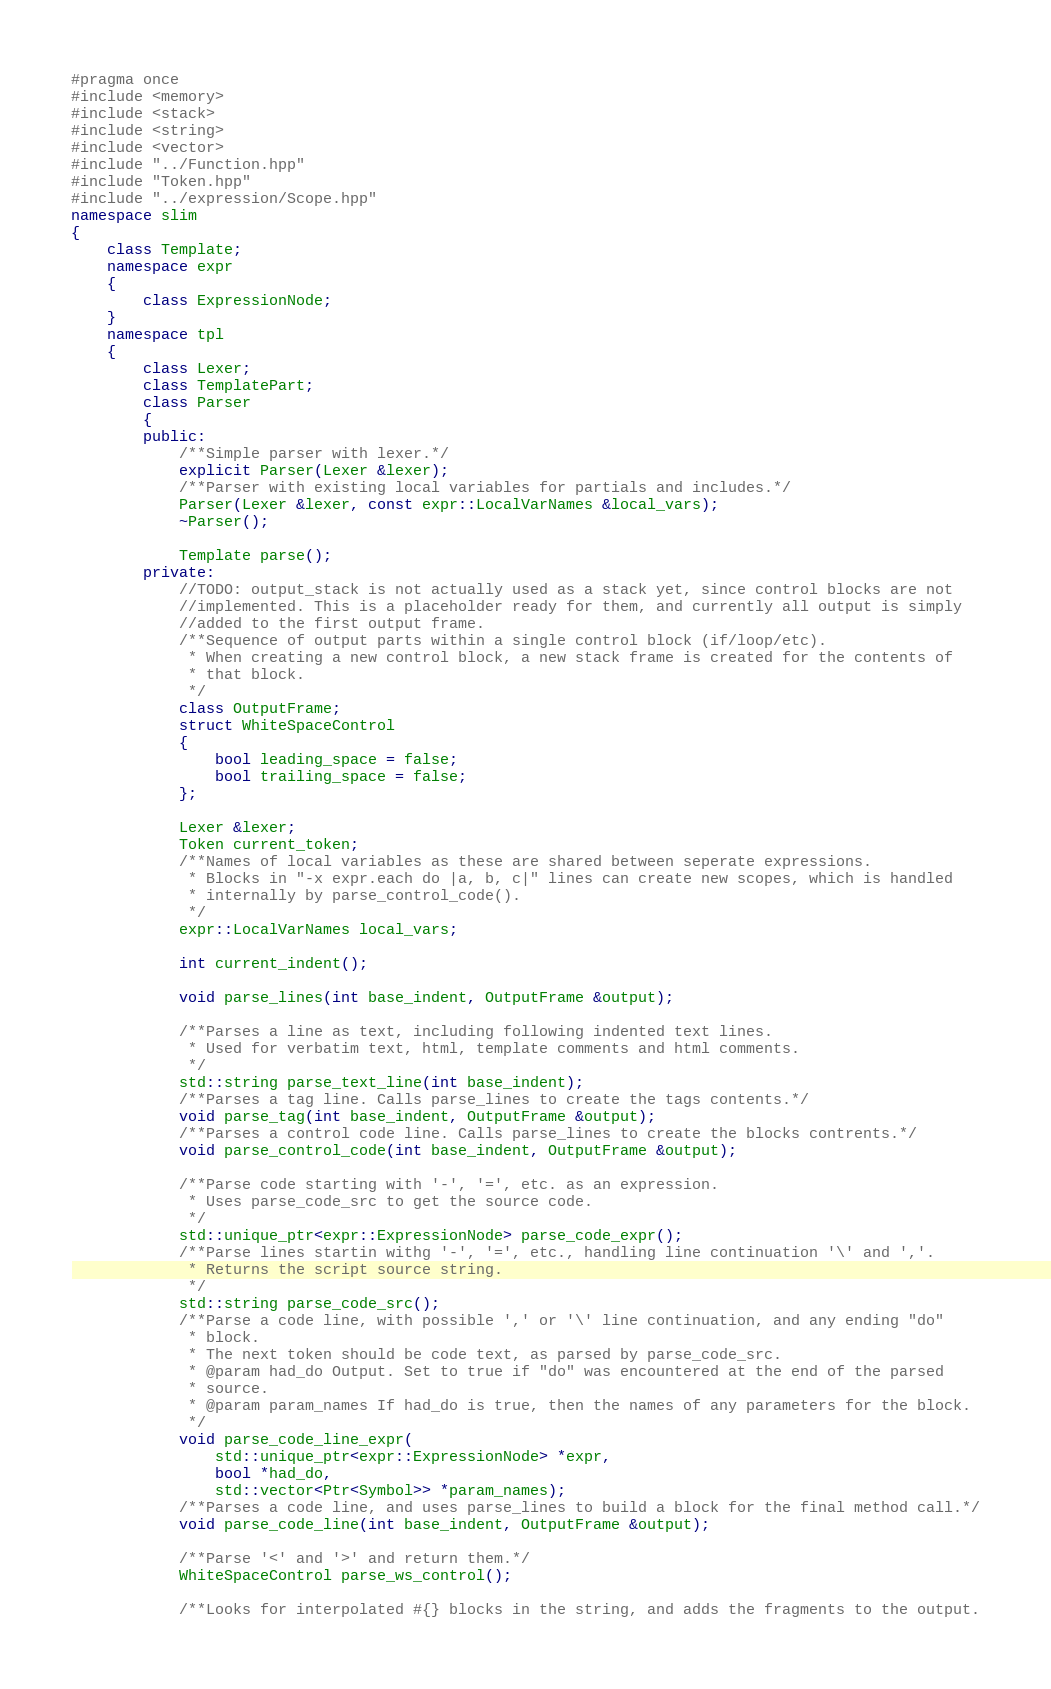Convert code to text. <code><loc_0><loc_0><loc_500><loc_500><_C++_>#pragma once
#include <memory>
#include <stack>
#include <string>
#include <vector>
#include "../Function.hpp"
#include "Token.hpp"
#include "../expression/Scope.hpp"
namespace slim
{
    class Template;
    namespace expr
    {
        class ExpressionNode;
    }
    namespace tpl
    {
        class Lexer;
        class TemplatePart;
        class Parser
        {
        public:
            /**Simple parser with lexer.*/
            explicit Parser(Lexer &lexer);
            /**Parser with existing local variables for partials and includes.*/
            Parser(Lexer &lexer, const expr::LocalVarNames &local_vars);
            ~Parser();

            Template parse();
        private:
            //TODO: output_stack is not actually used as a stack yet, since control blocks are not
            //implemented. This is a placeholder ready for them, and currently all output is simply
            //added to the first output frame.
            /**Sequence of output parts within a single control block (if/loop/etc).
             * When creating a new control block, a new stack frame is created for the contents of
             * that block.
             */
            class OutputFrame;
            struct WhiteSpaceControl
            {
                bool leading_space = false;
                bool trailing_space = false;
            };

            Lexer &lexer;
            Token current_token;
            /**Names of local variables as these are shared between seperate expressions.
             * Blocks in "-x expr.each do |a, b, c|" lines can create new scopes, which is handled
             * internally by parse_control_code().
             */
            expr::LocalVarNames local_vars;

            int current_indent();

            void parse_lines(int base_indent, OutputFrame &output);

            /**Parses a line as text, including following indented text lines.
             * Used for verbatim text, html, template comments and html comments.
             */
            std::string parse_text_line(int base_indent);
            /**Parses a tag line. Calls parse_lines to create the tags contents.*/
            void parse_tag(int base_indent, OutputFrame &output);
            /**Parses a control code line. Calls parse_lines to create the blocks contrents.*/
            void parse_control_code(int base_indent, OutputFrame &output);

            /**Parse code starting with '-', '=', etc. as an expression.
             * Uses parse_code_src to get the source code.
             */
            std::unique_ptr<expr::ExpressionNode> parse_code_expr();
            /**Parse lines startin withg '-', '=', etc., handling line continuation '\' and ','.
             * Returns the script source string.
             */
            std::string parse_code_src();
            /**Parse a code line, with possible ',' or '\' line continuation, and any ending "do"
             * block.
             * The next token should be code text, as parsed by parse_code_src.
             * @param had_do Output. Set to true if "do" was encountered at the end of the parsed
             * source.
             * @param param_names If had_do is true, then the names of any parameters for the block.
             */
            void parse_code_line_expr(
                std::unique_ptr<expr::ExpressionNode> *expr,
                bool *had_do,
                std::vector<Ptr<Symbol>> *param_names);
            /**Parses a code line, and uses parse_lines to build a block for the final method call.*/
            void parse_code_line(int base_indent, OutputFrame &output);

            /**Parse '<' and '>' and return them.*/
            WhiteSpaceControl parse_ws_control();

            /**Looks for interpolated #{} blocks in the string, and adds the fragments to the output.</code> 